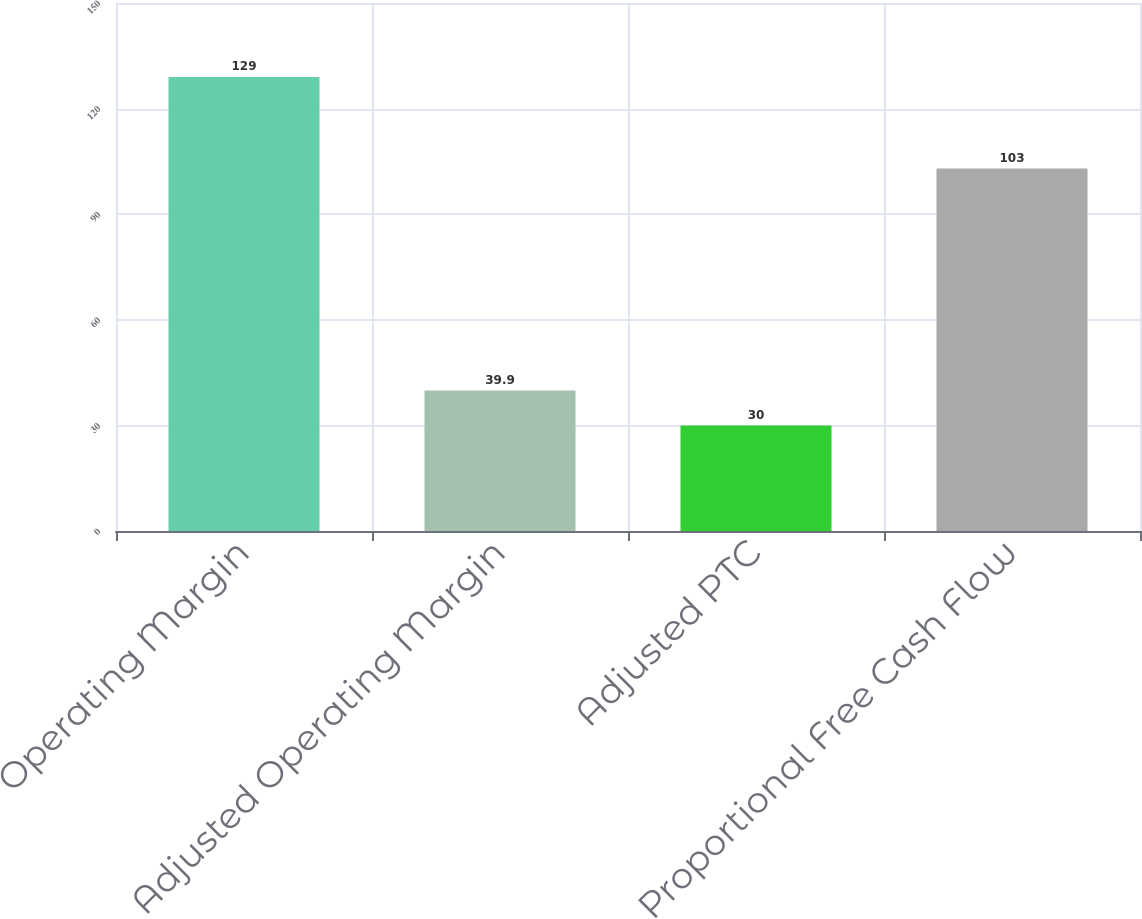Convert chart. <chart><loc_0><loc_0><loc_500><loc_500><bar_chart><fcel>Operating Margin<fcel>Adjusted Operating Margin<fcel>Adjusted PTC<fcel>Proportional Free Cash Flow<nl><fcel>129<fcel>39.9<fcel>30<fcel>103<nl></chart> 